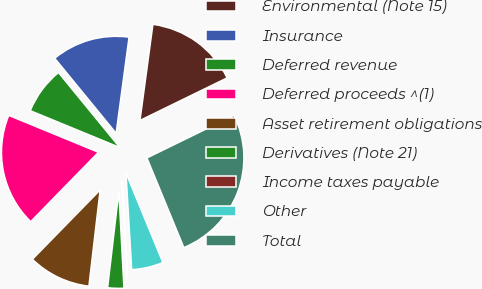<chart> <loc_0><loc_0><loc_500><loc_500><pie_chart><fcel>Environmental (Note 15)<fcel>Insurance<fcel>Deferred revenue<fcel>Deferred proceeds ^(1)<fcel>Asset retirement obligations<fcel>Derivatives (Note 21)<fcel>Income taxes payable<fcel>Other<fcel>Total<nl><fcel>15.64%<fcel>13.05%<fcel>7.87%<fcel>18.9%<fcel>10.46%<fcel>2.69%<fcel>0.1%<fcel>5.28%<fcel>26.01%<nl></chart> 